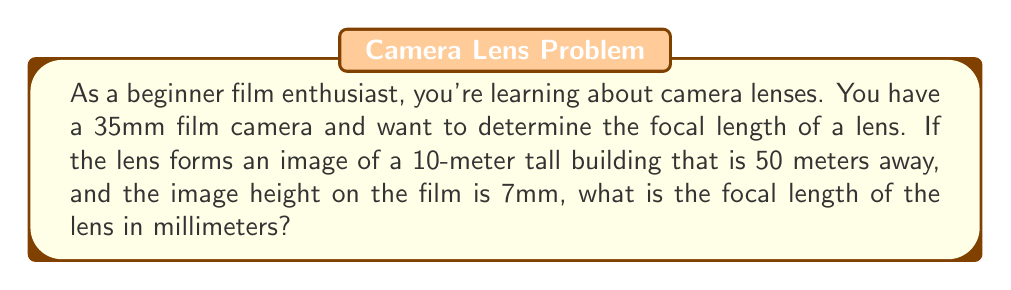Provide a solution to this math problem. To solve this problem, we'll use the lens equation and the magnification formula. Let's break it down step-by-step:

1) The lens equation is:
   $$\frac{1}{f} = \frac{1}{u} + \frac{1}{v}$$
   Where $f$ is the focal length, $u$ is the object distance, and $v$ is the image distance.

2) The magnification formula is:
   $$M = \frac{h_i}{h_o} = -\frac{v}{u}$$
   Where $M$ is magnification, $h_i$ is image height, and $h_o$ is object height.

3) We know:
   - Object distance $u = 50$ meters = 50,000 mm
   - Object height $h_o = 10$ meters = 10,000 mm
   - Image height $h_i = 7$ mm

4) Let's find the magnification:
   $$M = \frac{h_i}{h_o} = \frac{7}{10,000} = -0.0007$$

5) Using the magnification formula:
   $$-0.0007 = -\frac{v}{50,000}$$
   $$v = 35\text{ mm}$$

6) Now we have $u$ and $v$, we can use the lens equation:
   $$\frac{1}{f} = \frac{1}{50,000} + \frac{1}{35}$$

7) Solving for $f$:
   $$\frac{1}{f} = \frac{1}{50,000} + \frac{1}{35}$$
   $$\frac{1}{f} = 0.00002 + 0.02857 = 0.02859$$
   $$f = \frac{1}{0.02859} \approx 34.98\text{ mm}$$

Therefore, the focal length of the lens is approximately 35 mm.
Answer: $35\text{ mm}$ 